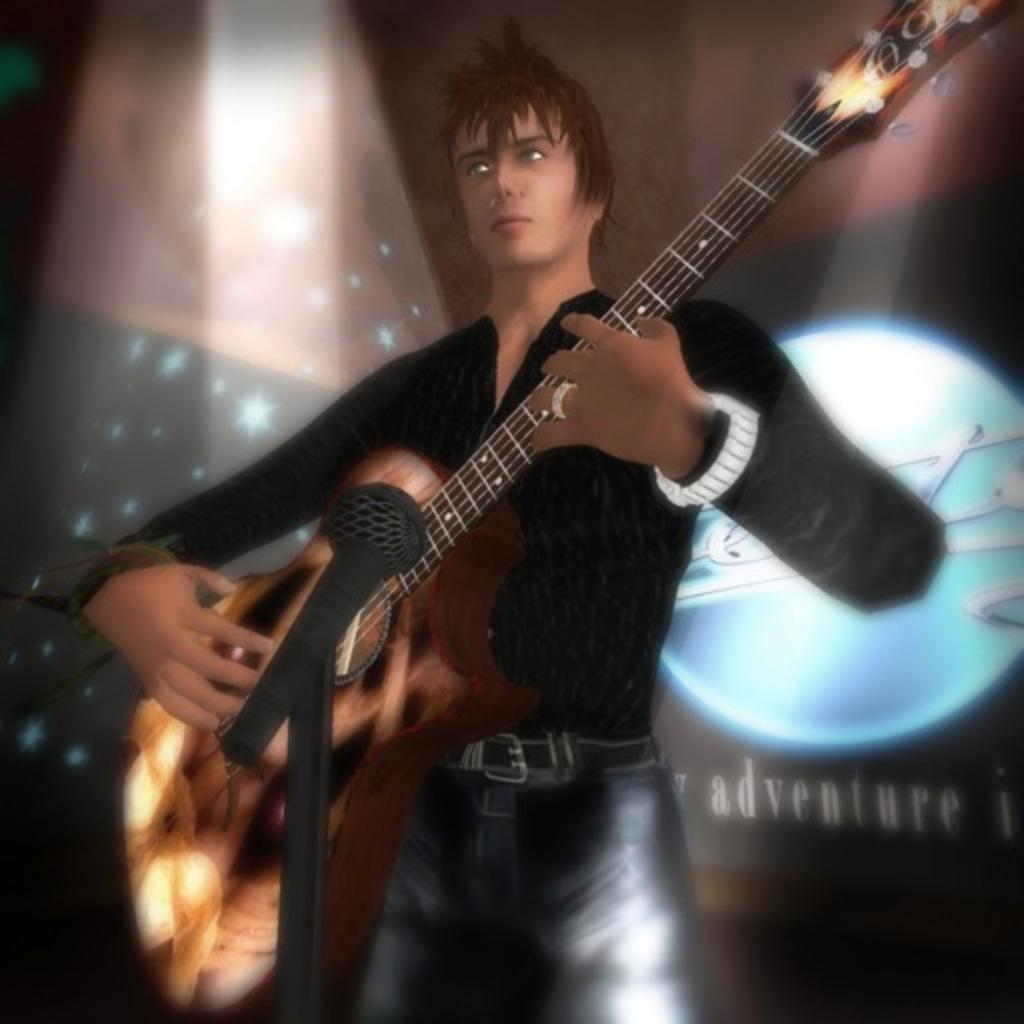What type of picture is in the image? The image contains an animated picture. Can you describe the person in the image? There is a person standing in the image. What is the person holding in the image? The person is holding a musical instrument. What can be seen in the background of the image? There are lights visible in the background of the image. Reasoning: Let'g: Let's think step by step in order to produce the conversation. We start by identifying the main subject of the image, which is the animated picture. Then, we describe the person and their actions, noting that they are standing and holding a musical instrument. Finally, we mention the background elements, specifically the lights. Each question is designed to elicit a specific detail about the image that is known from the provided facts. Absurd Question/Answer: What type of egg is being used as a bookmark in the image? There is no egg or book present in the image, so it cannot be determined if an egg is being used as a bookmark. 